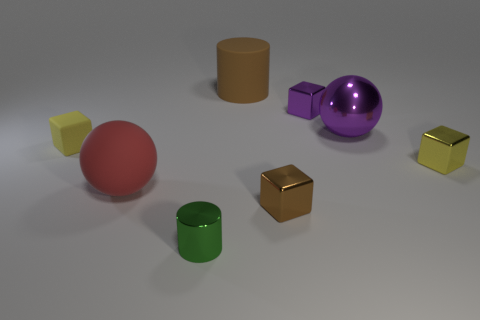Subtract all yellow cubes. How many were subtracted if there are1yellow cubes left? 1 Subtract all rubber blocks. How many blocks are left? 3 Subtract all purple blocks. How many blocks are left? 3 Add 6 small rubber blocks. How many small rubber blocks exist? 7 Add 1 large purple rubber balls. How many objects exist? 9 Subtract 1 yellow blocks. How many objects are left? 7 Subtract all cylinders. How many objects are left? 6 Subtract 1 cylinders. How many cylinders are left? 1 Subtract all purple balls. Subtract all green blocks. How many balls are left? 1 Subtract all purple balls. How many blue cylinders are left? 0 